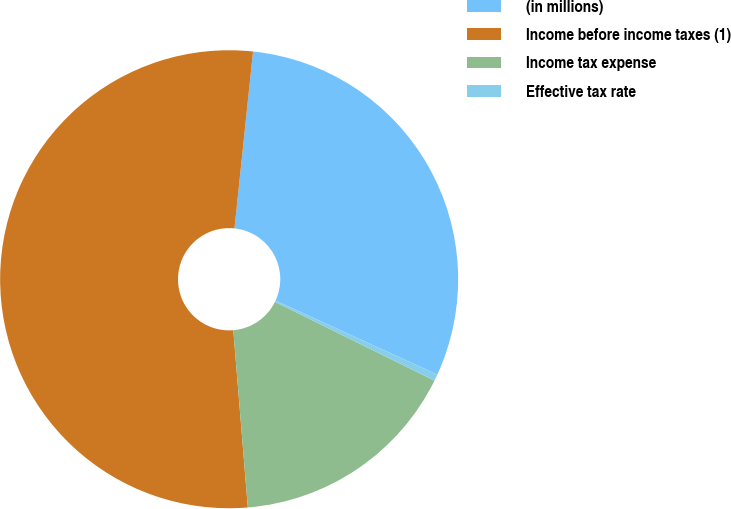<chart> <loc_0><loc_0><loc_500><loc_500><pie_chart><fcel>(in millions)<fcel>Income before income taxes (1)<fcel>Income tax expense<fcel>Effective tax rate<nl><fcel>30.17%<fcel>52.96%<fcel>16.4%<fcel>0.46%<nl></chart> 